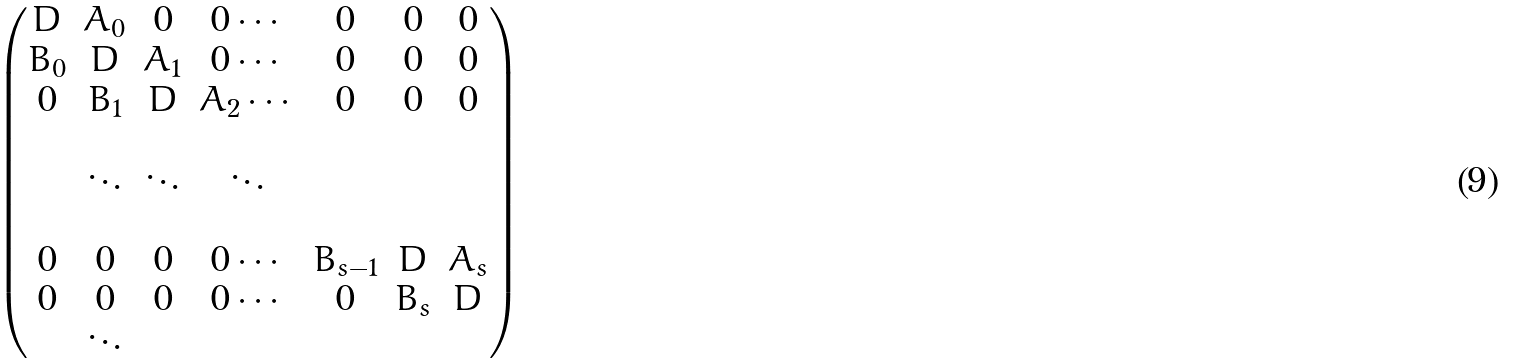Convert formula to latex. <formula><loc_0><loc_0><loc_500><loc_500>\begin{pmatrix} D & A _ { 0 } & 0 & 0 \cdots & 0 & 0 & 0 \\ B _ { 0 } & D & A _ { 1 } & 0 \cdots & 0 & 0 & 0 \\ 0 & B _ { 1 } & D & A _ { 2 } \cdots & 0 & 0 & 0 \\ \\ \quad & \ddots & \ddots & \ddots & \\ \\ 0 & 0 & 0 & 0 \cdots & B _ { s - 1 } & D & A _ { s } \\ 0 & 0 & 0 & 0 \cdots & 0 & B _ { s } & D \\ \quad & \ddots \end{pmatrix}</formula> 